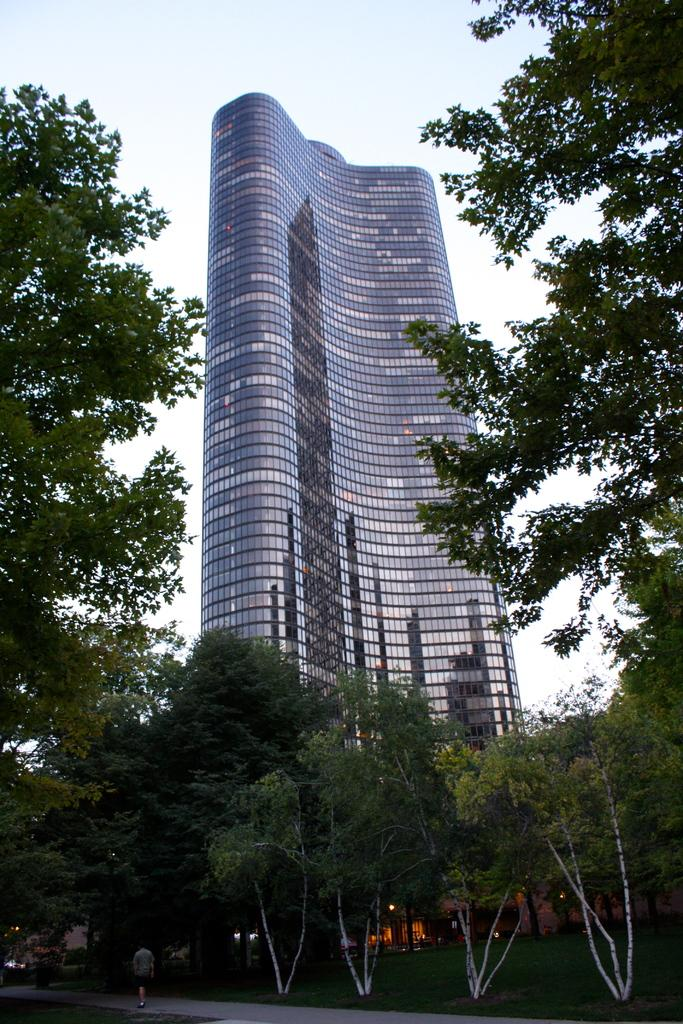What is the person in the image doing? There is a person walking on the road in the image. What type of vegetation can be seen in the image? There is grass visible in the image. What can be seen in the background of the image? There are trees and a tower building in the background of the image. What is visible in the sky in the image? The sky is visible in the background of the image. What type of pets are visible in the image? There are no pets visible in the image. How does the fog affect the visibility in the image? There is no fog present in the image, so it does not affect the visibility. 